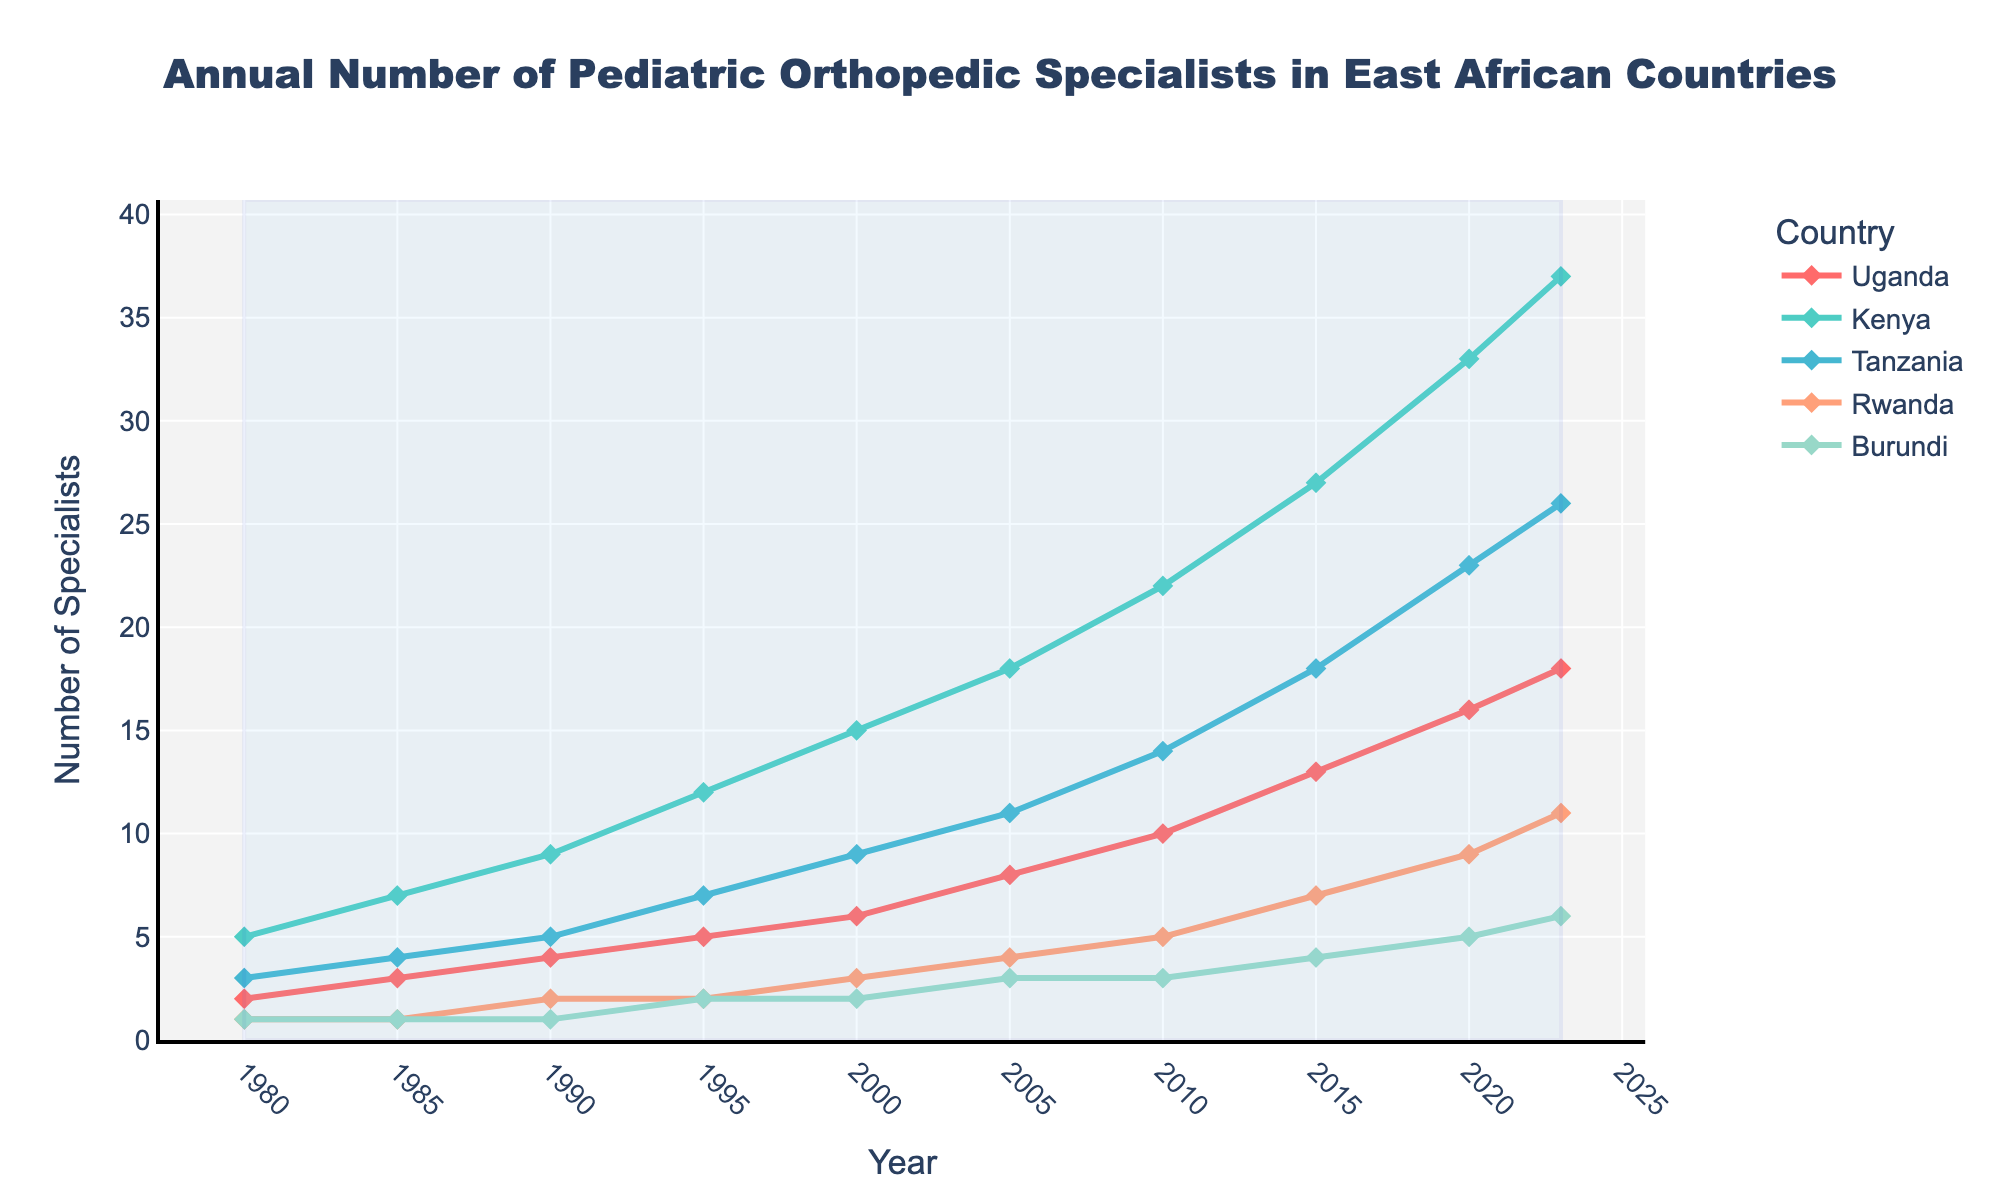What is the overall trend for the number of pediatric orthopedic specialists in Uganda from 1980 to 2023? The trend for Uganda shows a consistent increase in the number of pediatric orthopedic specialists over the years. Starting from 2 specialists in 1980, the number steadily rises to 18 by 2023.
Answer: The number has increased steadily Which country has the highest number of pediatric orthopedic specialists in 2023? In 2023, Kenya has the highest number of specialists. By visually comparing the ending points of each line on the graph, Kenya's line ends highest at around 37 specialists.
Answer: Kenya Between 1995 and 2005, which country experienced the greatest increase in the number of pediatric orthopedic specialists? The greatest increase is observed in Kenya. In 1995, Kenya had 12 specialists, and by 2005, this number increased to 18. This is a rise of 6 specialists.
Answer: Kenya How does the growth rate of pediatric orthopedic specialists in Uganda compare to that in Rwanda from 1980 to 2023? Uganda shows a more consistent and higher growth rate compared to Rwanda. Uganda grows from 2 to 18 specialists, while Rwanda increases from 1 to 11 specialists. The total change for Uganda is 16 specialists, and for Rwanda, it is 10 specialists.
Answer: Uganda's growth rate is higher By how many specialists did Tanzania surpass Burundi in 2020? In 2020, Tanzania had 23 specialists, while Burundi had 5 specialists. The difference between Tanzania and Burundi is 23 - 5 = 18 specialists.
Answer: 18 specialists What is the color associated with Uganda on the plot? Uganda is depicted with a red line on the plot. Each country is represented by a different color, and Uganda's line is consistently red throughout the chart.
Answer: Red What is the average number of pediatric orthopedic specialists in Uganda between 1980 and 2023? Sum the values for Uganda and divide by the number of data points: (2+3+4+5+6+8+10+13+16+18) = 85, divided by 10 data points, gives an average of 85/10 = 8.5 specialists.
Answer: 8.5 specialists Which country shows the slowest growth in the number of pediatric orthopedic specialists from 1980 to 2023? Burundi shows the slowest growth. Starting with 1 specialist in 1980 and increasing to 6 specialists by 2023, representing the smallest change among the countries.
Answer: Burundi 